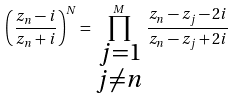<formula> <loc_0><loc_0><loc_500><loc_500>\left ( \frac { z _ { n } - i } { z _ { n } + i } \right ) ^ { N } = \prod _ { \begin{smallmatrix} j = 1 \\ j \neq n \end{smallmatrix} } ^ { M } \frac { z _ { n } - z _ { j } - 2 i } { z _ { n } - z _ { j } + 2 i }</formula> 